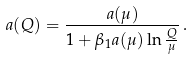<formula> <loc_0><loc_0><loc_500><loc_500>a ( Q ) = \frac { a ( \mu ) } { 1 + \beta _ { 1 } a ( \mu ) \ln \frac { Q } { \mu } } \, .</formula> 